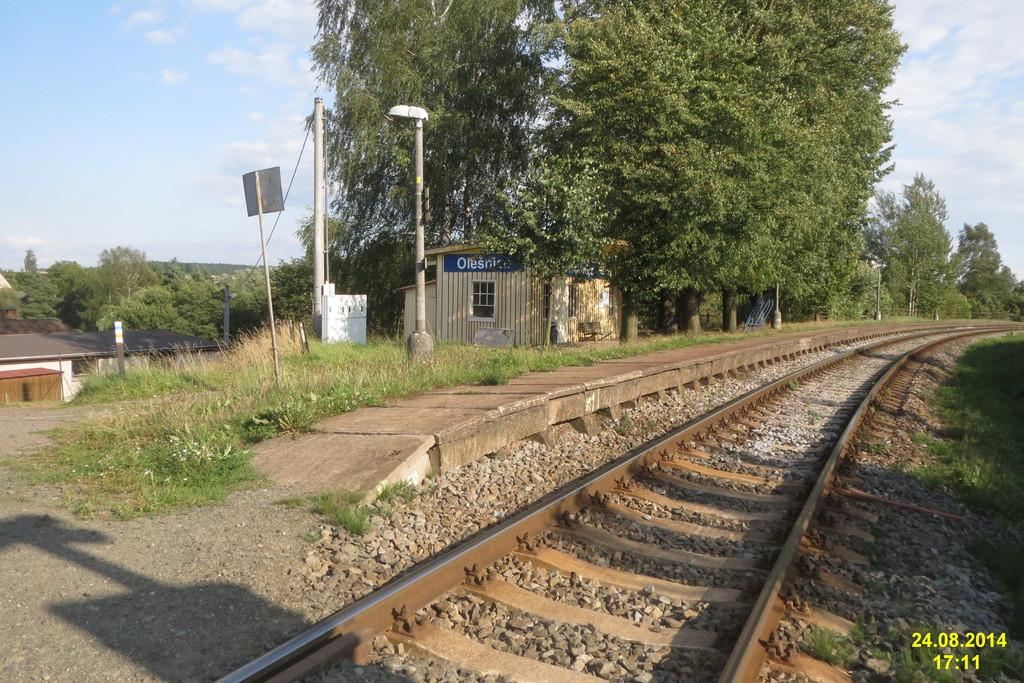What type of transportation infrastructure is visible in the image? There is a railway track in the image. What type of lighting is present along the railway track? Street lamps are present in the image. What type of residential structures can be seen in the image? There are houses in the image. What type of vegetation is visible in the image? Trees are visible in the image. What part of the natural environment is visible in the image? The sky is visible in the image. What type of weather can be inferred from the image? Clouds are present in the sky, suggesting that it might be a partly cloudy day. Can you describe the vein pattern on the leaves of the trees in the image? There is no specific detail about the vein pattern on the leaves of the trees in the image. The image only shows trees in general, without focusing on the leaves or their vein patterns. 